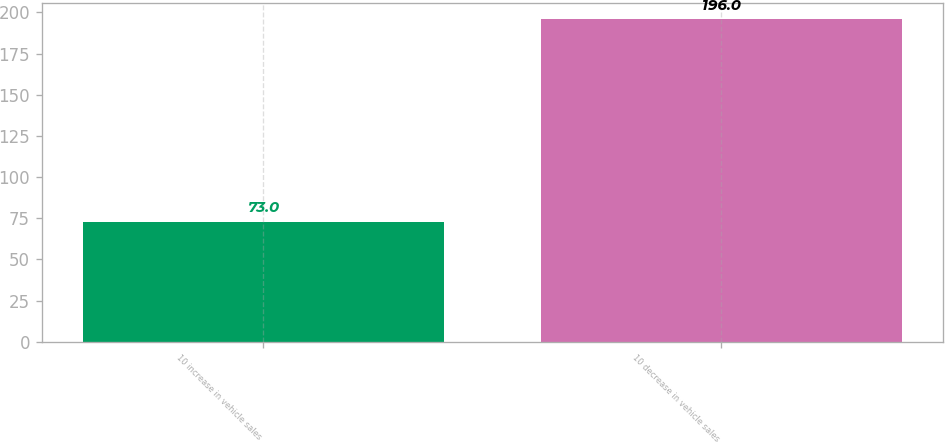<chart> <loc_0><loc_0><loc_500><loc_500><bar_chart><fcel>10 increase in vehicle sales<fcel>10 decrease in vehicle sales<nl><fcel>73<fcel>196<nl></chart> 